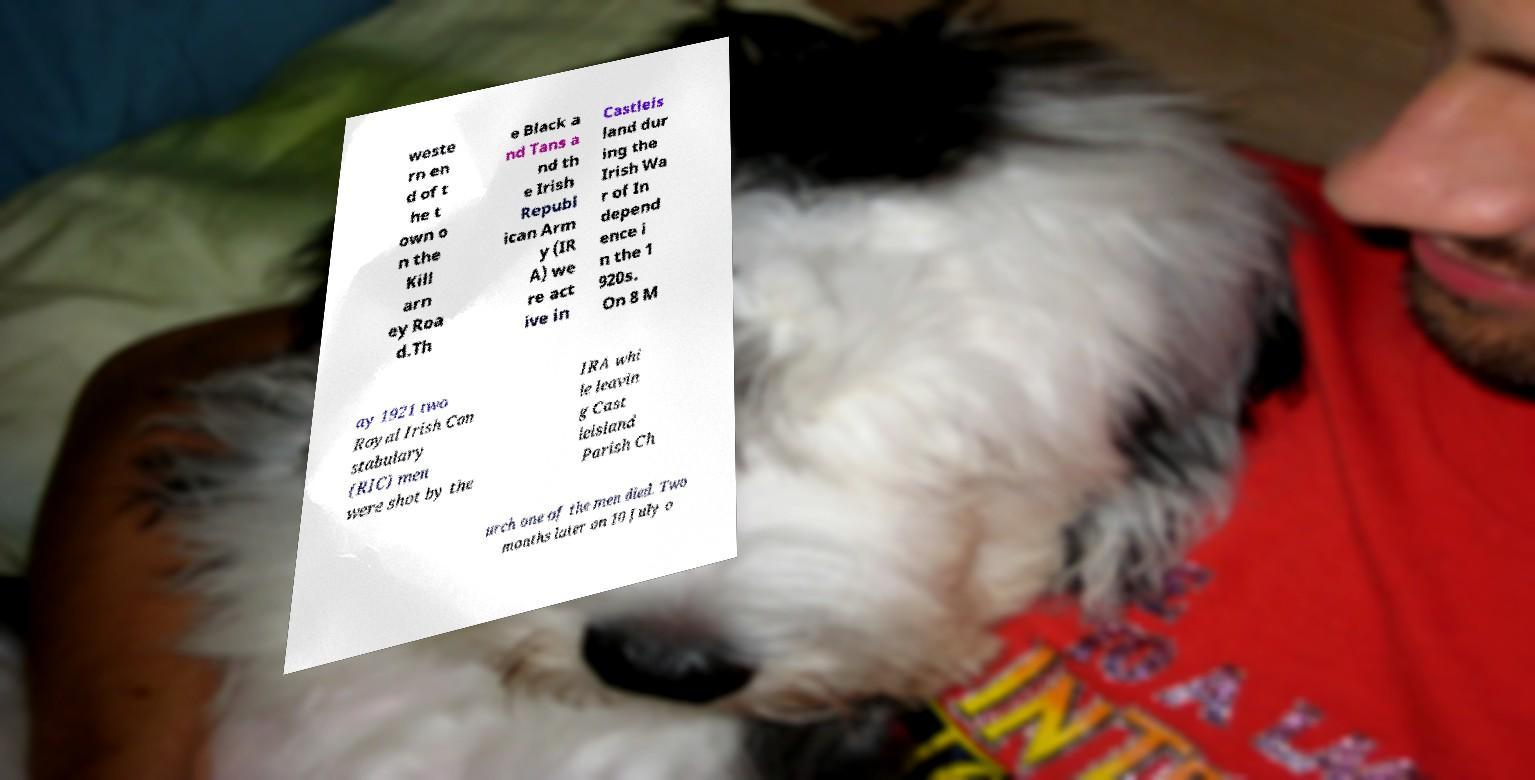Can you read and provide the text displayed in the image?This photo seems to have some interesting text. Can you extract and type it out for me? weste rn en d of t he t own o n the Kill arn ey Roa d.Th e Black a nd Tans a nd th e Irish Republ ican Arm y (IR A) we re act ive in Castleis land dur ing the Irish Wa r of In depend ence i n the 1 920s. On 8 M ay 1921 two Royal Irish Con stabulary (RIC) men were shot by the IRA whi le leavin g Cast leisland Parish Ch urch one of the men died. Two months later on 10 July o 